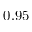<formula> <loc_0><loc_0><loc_500><loc_500>0 . 9 5</formula> 